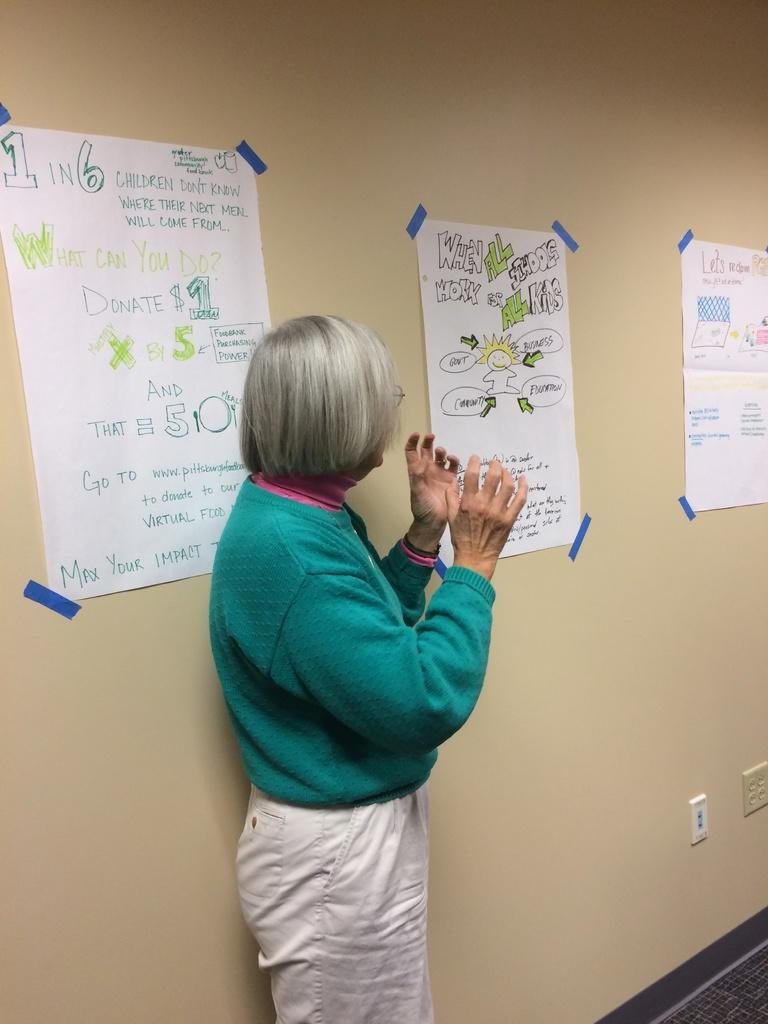Who is in the picture? There is a woman in the picture. What is the woman wearing? The woman is wearing a green sweater and white pants. Where is the woman located in the image? The woman is standing near a wall. What is attached to the wall? Charts are attached to the wall. What else can be seen on the wall? There are switch sockets on the wall. What type of crown is the woman wearing in the image? There is no crown present in the image; the woman is wearing a green sweater and white pants. 